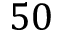Convert formula to latex. <formula><loc_0><loc_0><loc_500><loc_500>5 0</formula> 